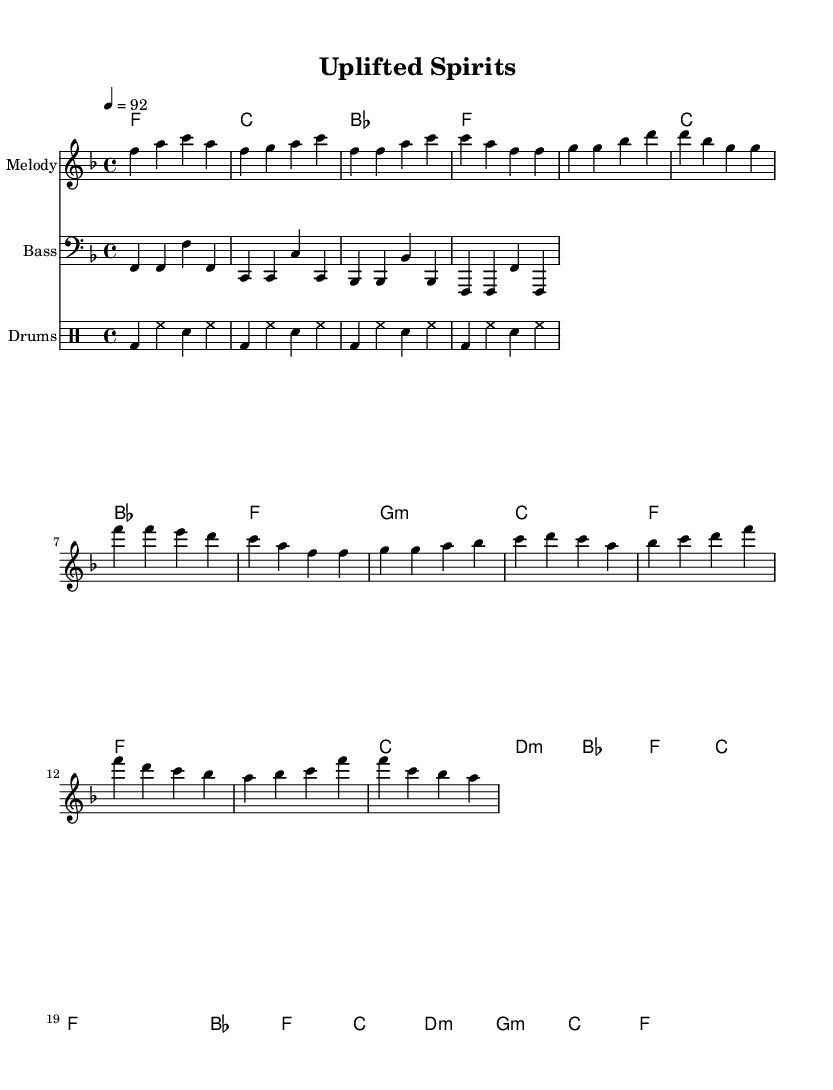What is the key signature of this music? The key signature is F major, which has one flat (B flat). This can be determined by looking at the key signature indicated at the beginning of the piece, located after the clef.
Answer: F major What is the time signature of the music? The time signature is 4/4, which means there are four beats per measure and the quarter note gets one beat. This is found at the start of the score, right after the key signature.
Answer: 4/4 What is the tempo marking for this piece? The tempo marking indicates a speed of quarters equals 92 beats per minute. This is specified in the tempo instruction at the beginning of the music.
Answer: 92 How many measures are in the chorus section? There are four measures in the chorus section, as shown by the group of four measure bars in the corresponding part of the melody.
Answer: 4 What is the main mood conveyed through the lyrics and music structure? The mood is uplifting, which can be interpreted from the positive lyrics implied in the context of gospel hip-hop and the jazzy undertones throughout the music.
Answer: Uplifting What type of chords are used in the verse section? The verse section primarily uses major and minor chords, specifically F major, C major, B flat major, and G minor chords as indicated in the harmonies provided.
Answer: Major and minor What rhythmic pattern do the drums follow? The rhythmic pattern of the drums follows a bass drum followed by hi-hat and snare alternation, creating a consistent groove typical of hip-hop beats. This pattern is evident from the notation in the drum staff.
Answer: Alternating 